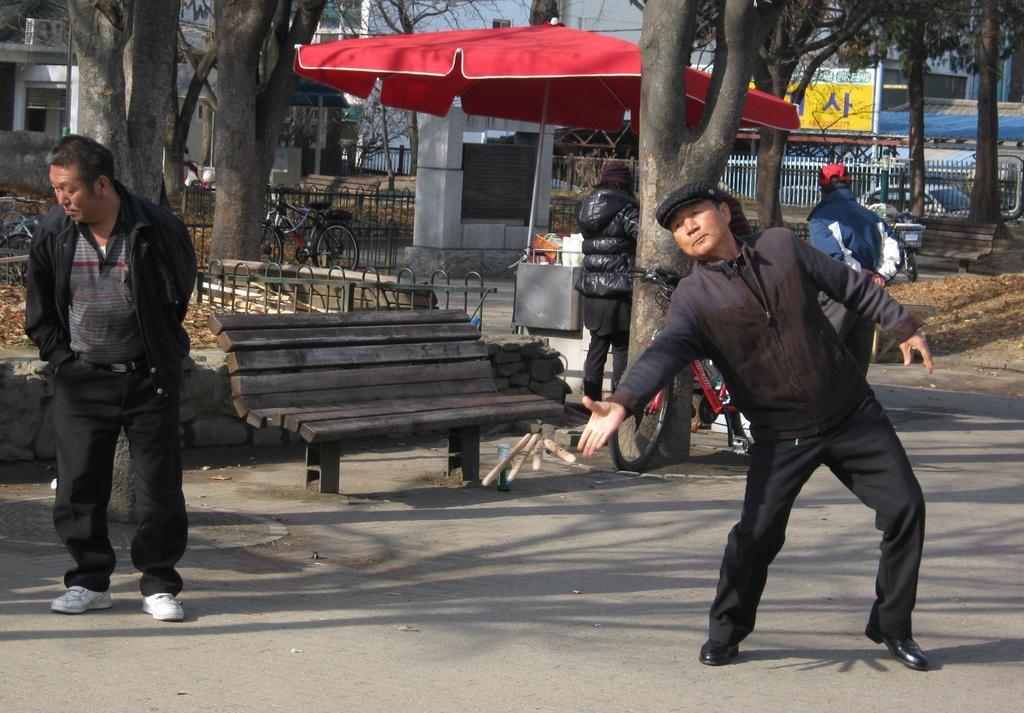Describe this image in one or two sentences. The four persons are standing on a road. We can see in background tent,bench,trees ,sky and buildings. 